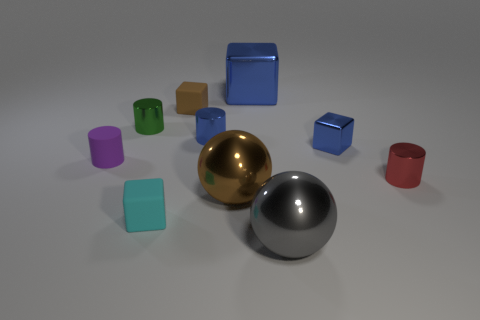The other tiny matte object that is the same shape as the small brown rubber thing is what color?
Provide a short and direct response. Cyan. There is a metal thing on the left side of the tiny matte thing that is in front of the tiny matte cylinder; what number of matte cubes are behind it?
Provide a short and direct response. 1. Is there any other thing that has the same material as the small green cylinder?
Offer a very short reply. Yes. Is the number of small rubber objects on the right side of the blue shiny cylinder less than the number of small cyan objects?
Ensure brevity in your answer.  Yes. Does the big block have the same color as the small metallic cube?
Give a very brief answer. Yes. What is the size of the green thing that is the same shape as the purple rubber object?
Give a very brief answer. Small. What number of small objects are the same material as the small purple cylinder?
Provide a short and direct response. 2. Does the small block right of the large brown metallic ball have the same material as the brown sphere?
Offer a terse response. Yes. Is the number of small cylinders behind the rubber cylinder the same as the number of blue objects?
Provide a short and direct response. No. The blue cylinder is what size?
Offer a terse response. Small. 